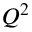Convert formula to latex. <formula><loc_0><loc_0><loc_500><loc_500>Q ^ { 2 }</formula> 